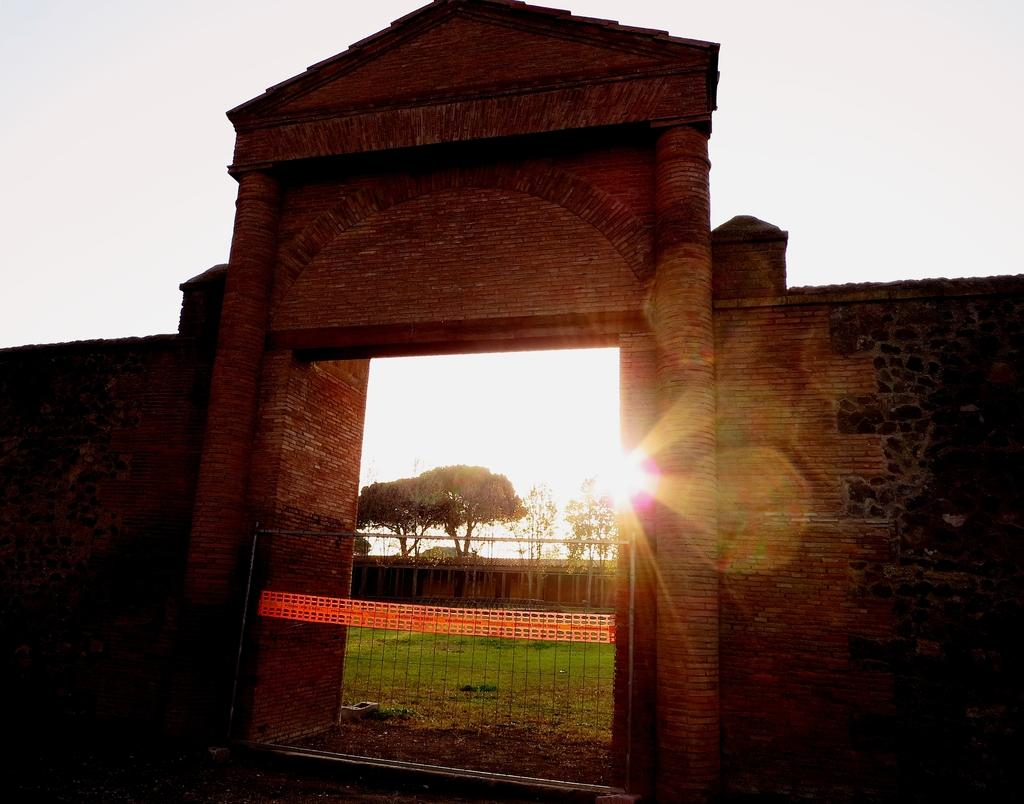What structure is located in the center of the image? There is an arch in the center of the image. What can be used for cooking in the image? There is a grill in the image. What type of natural scenery is visible in the background of the image? There are trees in the background of the image. What type of man-made structures can be seen in the background of the image? There are sheds in the background of the image. What is the source of light in the image? Sunlight is visible in the image. How many rakes are being used at the party in the image? There is no party or rake present in the image. What is the total number of guests attending the party in the image? There is no party present in the image, so it is not possible to determine the number of guests. 